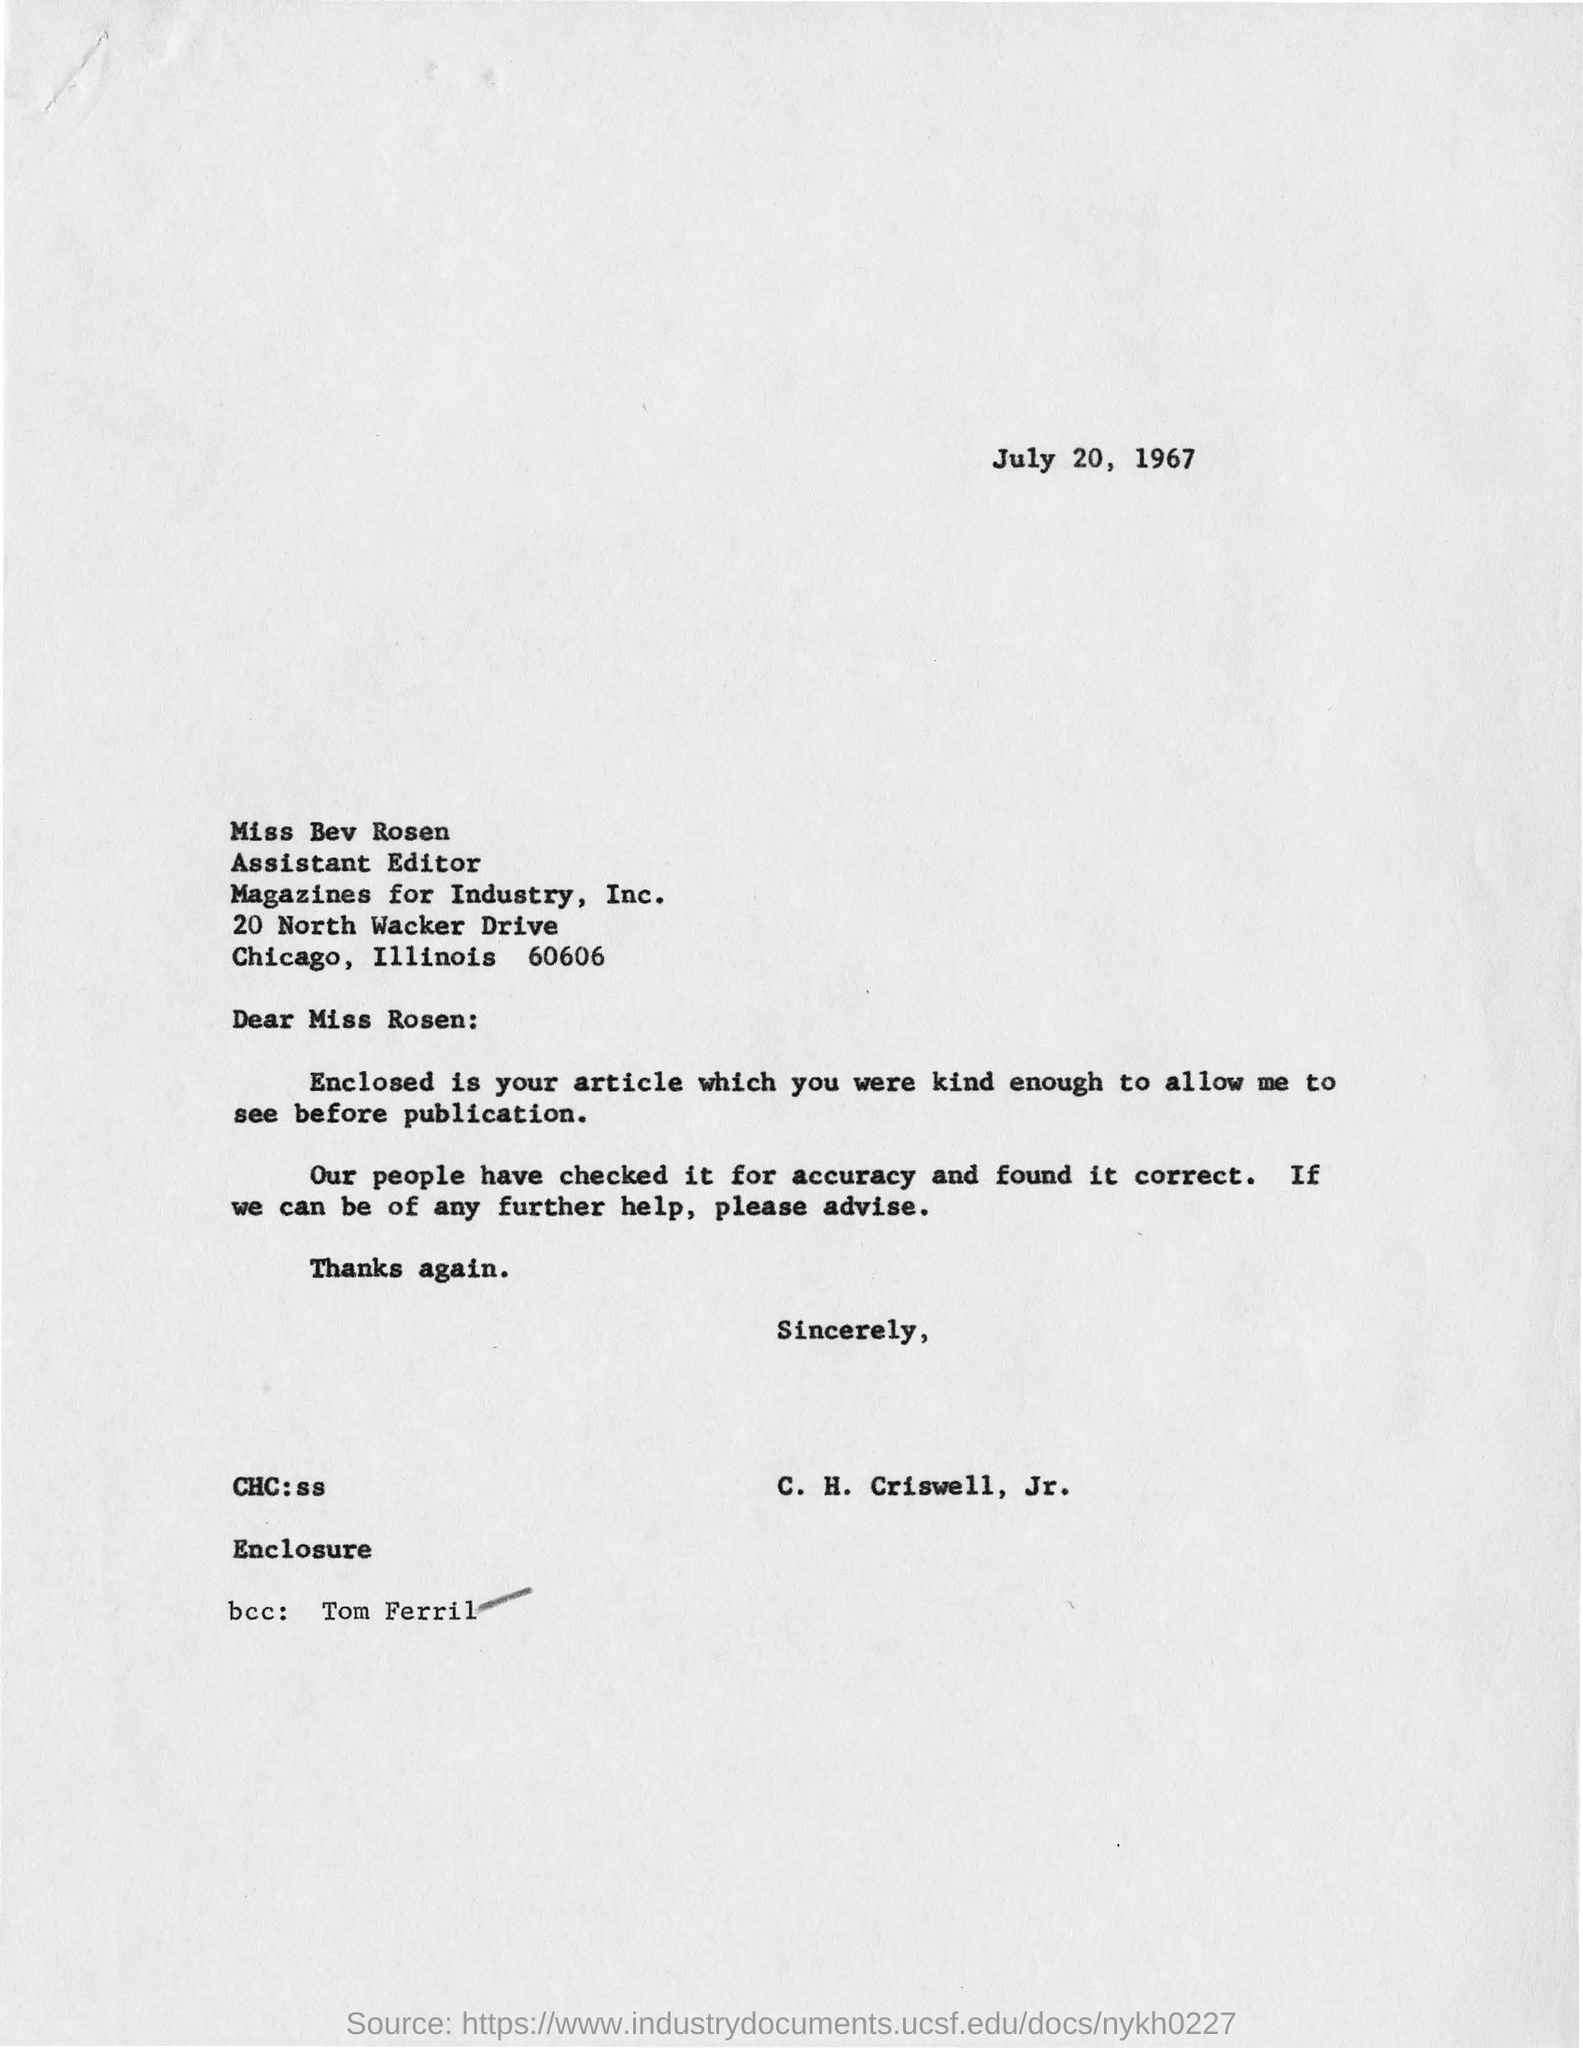What is the date mentioned?
Offer a terse response. July 20, 1967. To whom is this letter addressed?
Your answer should be compact. Miss Bev Rosen. Who sent the letter?
Make the answer very short. C. H. Criswell, Jr. Who is the bcc?
Ensure brevity in your answer.  Tom Ferril. 